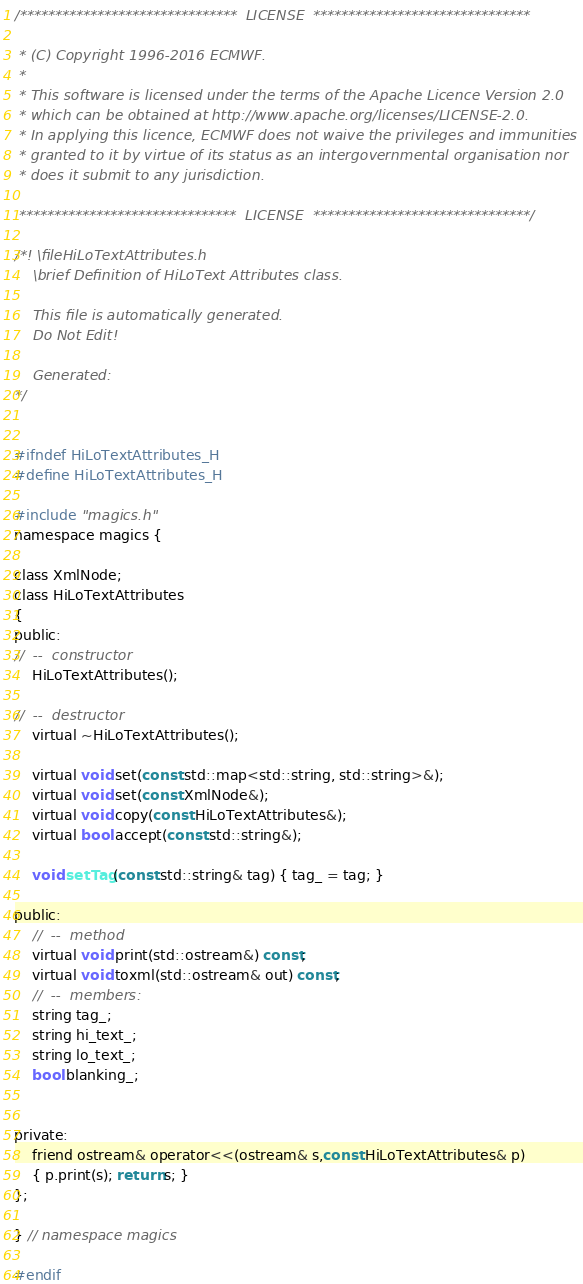<code> <loc_0><loc_0><loc_500><loc_500><_C_>
/*******************************  LICENSE  *******************************

 * (C) Copyright 1996-2016 ECMWF.
 * 
 * This software is licensed under the terms of the Apache Licence Version 2.0
 * which can be obtained at http://www.apache.org/licenses/LICENSE-2.0. 
 * In applying this licence, ECMWF does not waive the privileges and immunities 
 * granted to it by virtue of its status as an intergovernmental organisation nor
 * does it submit to any jurisdiction.

 *******************************  LICENSE  *******************************/

/*! \fileHiLoTextAttributes.h
    \brief Definition of HiLoText Attributes class.

    This file is automatically generated.
    Do Not Edit!

    Generated: 
*/
   

#ifndef HiLoTextAttributes_H
#define HiLoTextAttributes_H

#include "magics.h"
namespace magics {

class XmlNode;
class HiLoTextAttributes 
{
public:
//  --  constructor
    HiLoTextAttributes();
    
//  --  destructor
    virtual ~HiLoTextAttributes();
    
    virtual void set(const std::map<std::string, std::string>&);
    virtual void set(const XmlNode&);
    virtual void copy(const HiLoTextAttributes&);
    virtual bool accept(const std::string&);

    void setTag(const std::string& tag) { tag_ = tag; }

public:
	//  --  method
	virtual void print(std::ostream&) const;
	virtual void toxml(std::ostream& out) const;
	//  --  members:
	string tag_;
	string hi_text_;
	string lo_text_;
	bool blanking_;
	 

private:
	friend ostream& operator<<(ostream& s,const HiLoTextAttributes& p)
	{ p.print(s); return s; }
};

} // namespace magics

#endif

</code> 